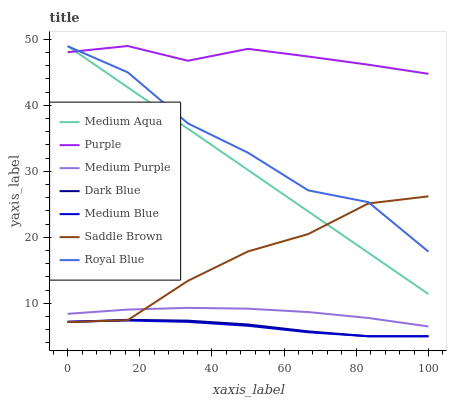Does Medium Blue have the minimum area under the curve?
Answer yes or no. Yes. Does Purple have the maximum area under the curve?
Answer yes or no. Yes. Does Purple have the minimum area under the curve?
Answer yes or no. No. Does Medium Blue have the maximum area under the curve?
Answer yes or no. No. Is Medium Aqua the smoothest?
Answer yes or no. Yes. Is Royal Blue the roughest?
Answer yes or no. Yes. Is Purple the smoothest?
Answer yes or no. No. Is Purple the roughest?
Answer yes or no. No. Does Medium Blue have the lowest value?
Answer yes or no. Yes. Does Purple have the lowest value?
Answer yes or no. No. Does Medium Aqua have the highest value?
Answer yes or no. Yes. Does Medium Blue have the highest value?
Answer yes or no. No. Is Medium Purple less than Purple?
Answer yes or no. Yes. Is Medium Aqua greater than Medium Blue?
Answer yes or no. Yes. Does Medium Blue intersect Dark Blue?
Answer yes or no. Yes. Is Medium Blue less than Dark Blue?
Answer yes or no. No. Is Medium Blue greater than Dark Blue?
Answer yes or no. No. Does Medium Purple intersect Purple?
Answer yes or no. No. 